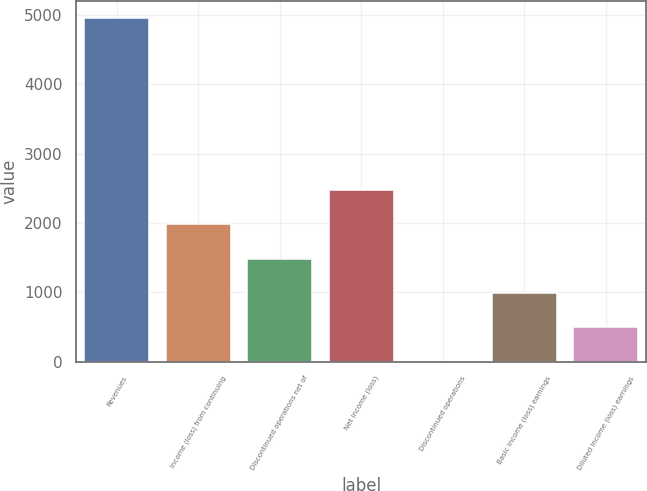Convert chart. <chart><loc_0><loc_0><loc_500><loc_500><bar_chart><fcel>Revenues<fcel>Income (loss) from continuing<fcel>Discontinued operations net of<fcel>Net income (loss)<fcel>Discontinued operations<fcel>Basic income (loss) earnings<fcel>Diluted income (loss) earnings<nl><fcel>4958<fcel>1983.31<fcel>1487.52<fcel>2479.1<fcel>0.15<fcel>991.73<fcel>495.94<nl></chart> 